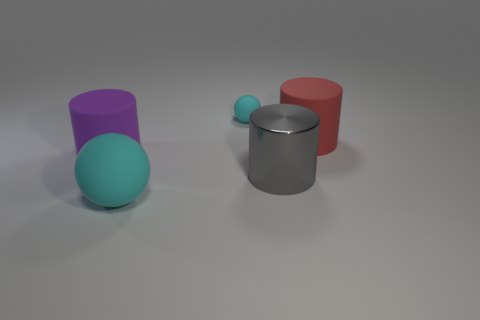Is there anything else that has the same material as the big gray cylinder?
Ensure brevity in your answer.  No. How many cylinders are either large purple things or red objects?
Your answer should be very brief. 2. Are the cyan thing that is in front of the metal cylinder and the cyan ball behind the large cyan rubber sphere made of the same material?
Make the answer very short. Yes. The gray shiny thing that is the same size as the red matte cylinder is what shape?
Your response must be concise. Cylinder. How many other things are there of the same color as the big matte sphere?
Keep it short and to the point. 1. What number of cyan objects are either tiny rubber objects or big metallic cylinders?
Your response must be concise. 1. There is a rubber object that is on the right side of the tiny cyan object; does it have the same shape as the cyan rubber thing that is in front of the large gray object?
Keep it short and to the point. No. How many other objects are the same material as the gray thing?
Your answer should be compact. 0. There is a cyan ball that is in front of the cylinder behind the purple rubber object; is there a tiny sphere that is left of it?
Keep it short and to the point. No. Are the purple cylinder and the red object made of the same material?
Offer a very short reply. Yes. 